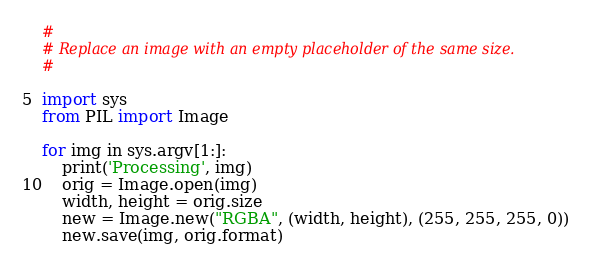<code> <loc_0><loc_0><loc_500><loc_500><_Python_>#
# Replace an image with an empty placeholder of the same size.
#

import sys
from PIL import Image

for img in sys.argv[1:]:
    print('Processing', img)
    orig = Image.open(img)
    width, height = orig.size
    new = Image.new("RGBA", (width, height), (255, 255, 255, 0))
    new.save(img, orig.format)
</code> 